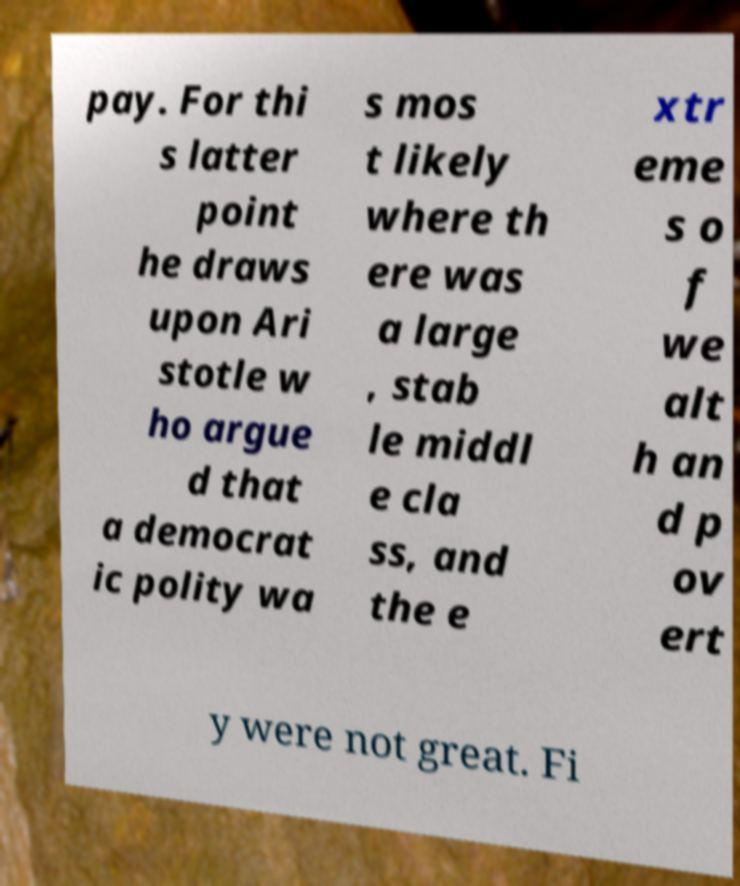Please read and relay the text visible in this image. What does it say? pay. For thi s latter point he draws upon Ari stotle w ho argue d that a democrat ic polity wa s mos t likely where th ere was a large , stab le middl e cla ss, and the e xtr eme s o f we alt h an d p ov ert y were not great. Fi 